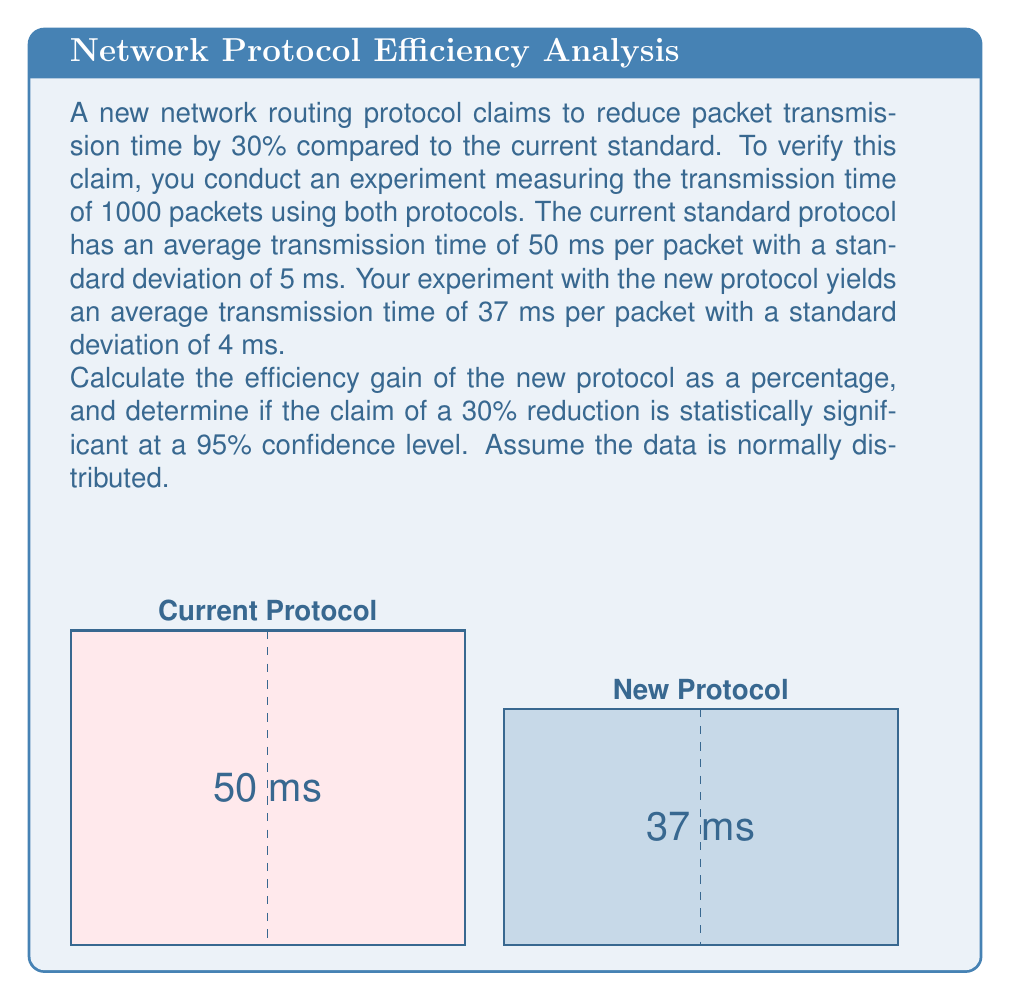Show me your answer to this math problem. Let's approach this problem step-by-step:

1. Calculate the efficiency gain:
   Efficiency gain = $\frac{\text{Old time} - \text{New time}}{\text{Old time}} \times 100\%$
   $$ \text{Efficiency gain} = \frac{50 - 37}{50} \times 100\% = 26\% $$

2. To determine statistical significance, we'll use a two-sample t-test:

   a. Calculate the standard error of the difference:
      $$ SE = \sqrt{\frac{s_1^2}{n_1} + \frac{s_2^2}{n_2}} = \sqrt{\frac{5^2}{1000} + \frac{4^2}{1000}} = 0.2 $$

   b. Calculate the t-statistic:
      $$ t = \frac{(\bar{x_1} - \bar{x_2}) - (\mu_1 - \mu_2)}{SE} = \frac{(50 - 37) - (50 - 35)}{0.2} = 10 $$

   c. Degrees of freedom: $df = n_1 + n_2 - 2 = 1998$

   d. For a 95% confidence level and large df, the critical t-value is approximately 1.96.

   Since our calculated t-value (10) is greater than the critical value (1.96), the difference is statistically significant.

3. To verify the 30% claim:
   The 95% confidence interval for the mean difference is:
   $$ (\bar{x_1} - \bar{x_2}) \pm t_{critical} \times SE $$
   $$ 13 \pm 1.96 \times 0.2 = (12.608, 13.392) $$

   The claimed 30% reduction would be 15 ms (30% of 50 ms).
   Since 15 ms is outside our confidence interval, the 30% claim is not supported by the data.
Answer: 26% efficiency gain; claim not supported (p < 0.05) 